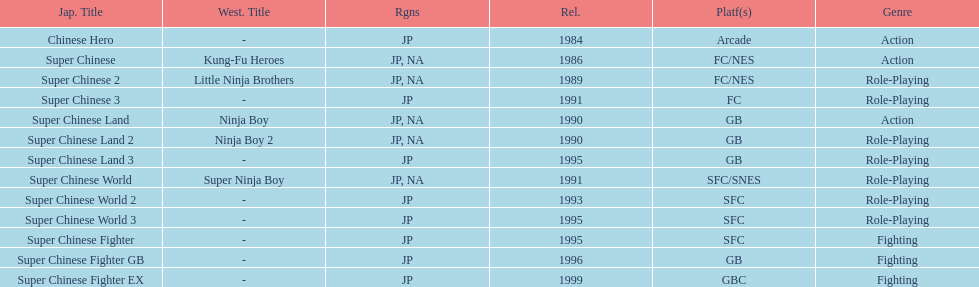What are the total of super chinese games released? 13. 